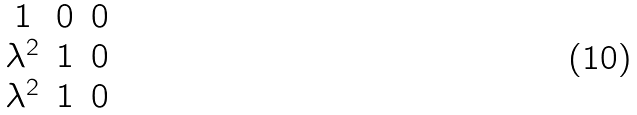Convert formula to latex. <formula><loc_0><loc_0><loc_500><loc_500>\begin{matrix} 1 & 0 & 0 \\ \lambda ^ { 2 } & 1 & 0 \\ \lambda ^ { 2 } & 1 & 0 \end{matrix}</formula> 